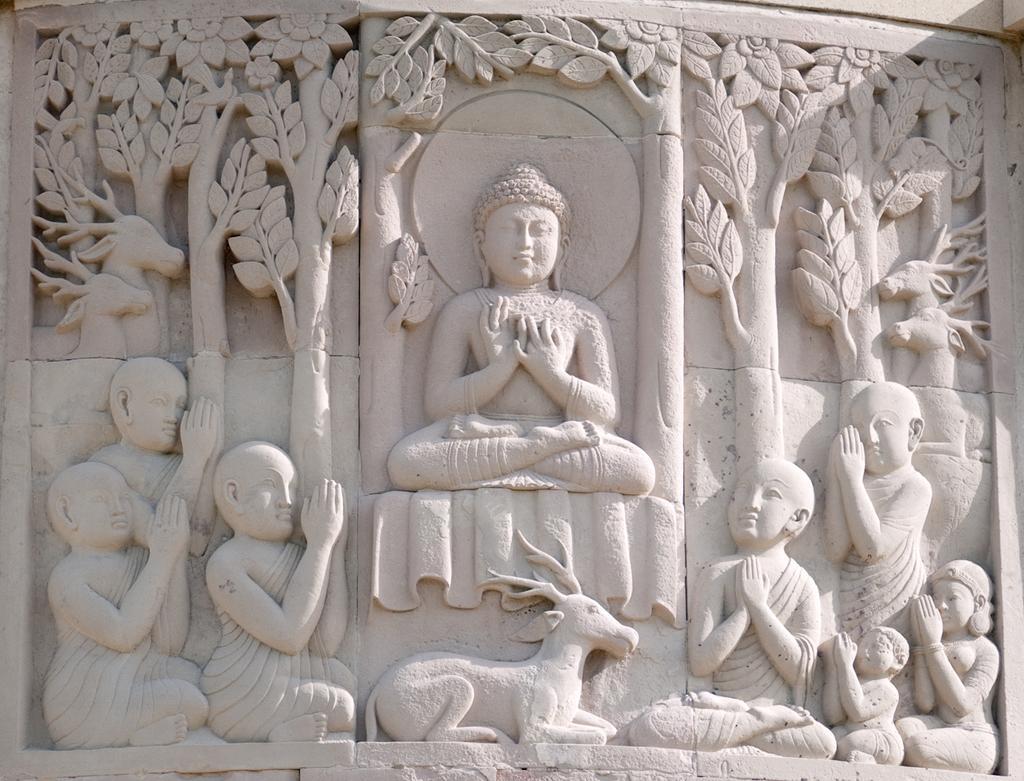How would you summarize this image in a sentence or two? In this image we can see the sculpture of a Buddha, many people, an animal and many trees on the wall in the image. 